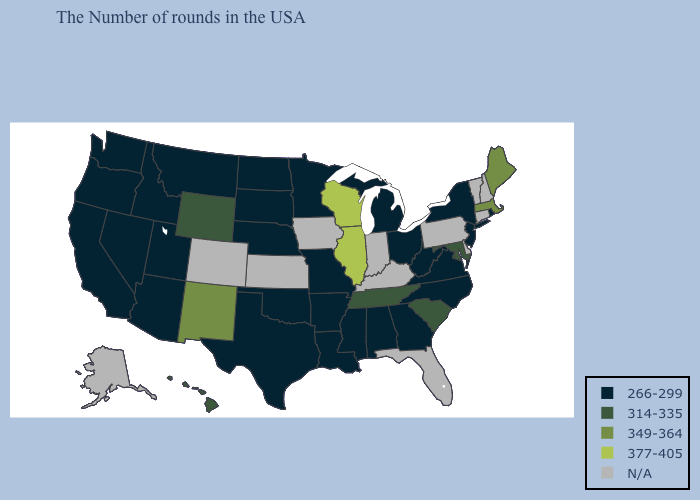Name the states that have a value in the range 349-364?
Write a very short answer. Maine, Massachusetts, New Mexico. Among the states that border Tennessee , which have the highest value?
Concise answer only. Virginia, North Carolina, Georgia, Alabama, Mississippi, Missouri, Arkansas. Name the states that have a value in the range 377-405?
Be succinct. Wisconsin, Illinois. What is the value of Ohio?
Short answer required. 266-299. What is the value of Delaware?
Quick response, please. N/A. Among the states that border South Carolina , which have the highest value?
Be succinct. North Carolina, Georgia. Name the states that have a value in the range 314-335?
Give a very brief answer. Maryland, South Carolina, Tennessee, Wyoming, Hawaii. What is the value of West Virginia?
Write a very short answer. 266-299. Which states hav the highest value in the South?
Quick response, please. Maryland, South Carolina, Tennessee. What is the value of Connecticut?
Be succinct. N/A. Name the states that have a value in the range N/A?
Quick response, please. New Hampshire, Vermont, Connecticut, Delaware, Pennsylvania, Florida, Kentucky, Indiana, Iowa, Kansas, Colorado, Alaska. What is the value of Alabama?
Quick response, please. 266-299. Name the states that have a value in the range N/A?
Concise answer only. New Hampshire, Vermont, Connecticut, Delaware, Pennsylvania, Florida, Kentucky, Indiana, Iowa, Kansas, Colorado, Alaska. Which states have the lowest value in the South?
Write a very short answer. Virginia, North Carolina, West Virginia, Georgia, Alabama, Mississippi, Louisiana, Arkansas, Oklahoma, Texas. 